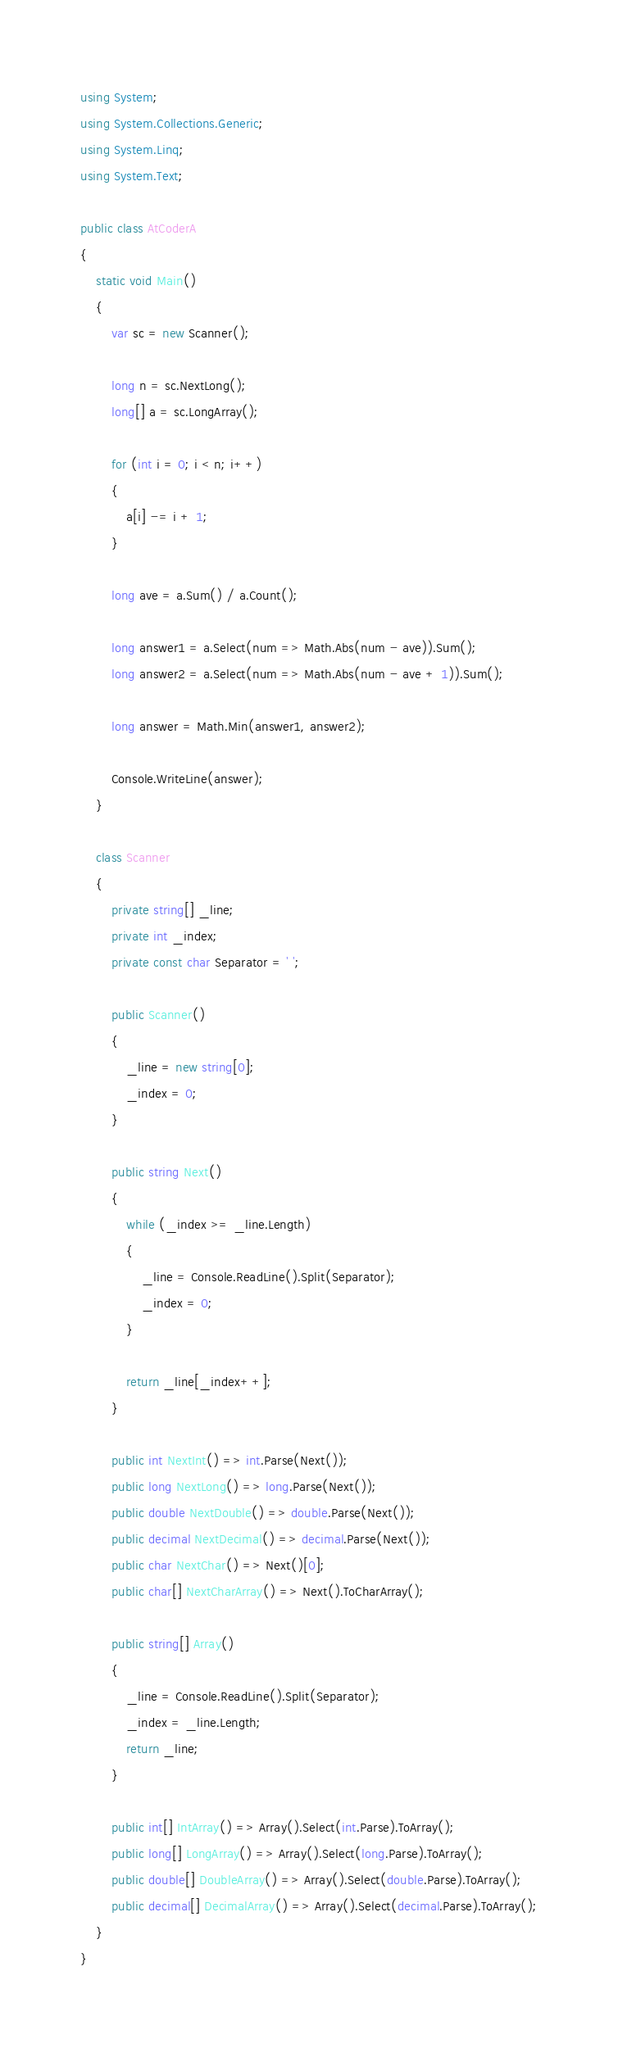Convert code to text. <code><loc_0><loc_0><loc_500><loc_500><_C#_>using System;
using System.Collections.Generic;
using System.Linq;
using System.Text;

public class AtCoderA
{
    static void Main()
    {
        var sc = new Scanner();

        long n = sc.NextLong();
        long[] a = sc.LongArray();

        for (int i = 0; i < n; i++)
        {
            a[i] -= i + 1;
        }

        long ave = a.Sum() / a.Count();

        long answer1 = a.Select(num => Math.Abs(num - ave)).Sum();
        long answer2 = a.Select(num => Math.Abs(num - ave + 1)).Sum();

        long answer = Math.Min(answer1, answer2);

        Console.WriteLine(answer);
    }

    class Scanner
    {
        private string[] _line;
        private int _index;
        private const char Separator = ' ';

        public Scanner()
        {
            _line = new string[0];
            _index = 0;
        }

        public string Next()
        {
            while (_index >= _line.Length)
            {
                _line = Console.ReadLine().Split(Separator);
                _index = 0;
            }

            return _line[_index++];
        }

        public int NextInt() => int.Parse(Next());
        public long NextLong() => long.Parse(Next());
        public double NextDouble() => double.Parse(Next());
        public decimal NextDecimal() => decimal.Parse(Next());
        public char NextChar() => Next()[0];
        public char[] NextCharArray() => Next().ToCharArray();

        public string[] Array()
        {
            _line = Console.ReadLine().Split(Separator);
            _index = _line.Length;
            return _line;
        }

        public int[] IntArray() => Array().Select(int.Parse).ToArray();
        public long[] LongArray() => Array().Select(long.Parse).ToArray();
        public double[] DoubleArray() => Array().Select(double.Parse).ToArray();
        public decimal[] DecimalArray() => Array().Select(decimal.Parse).ToArray();
    }
}
</code> 